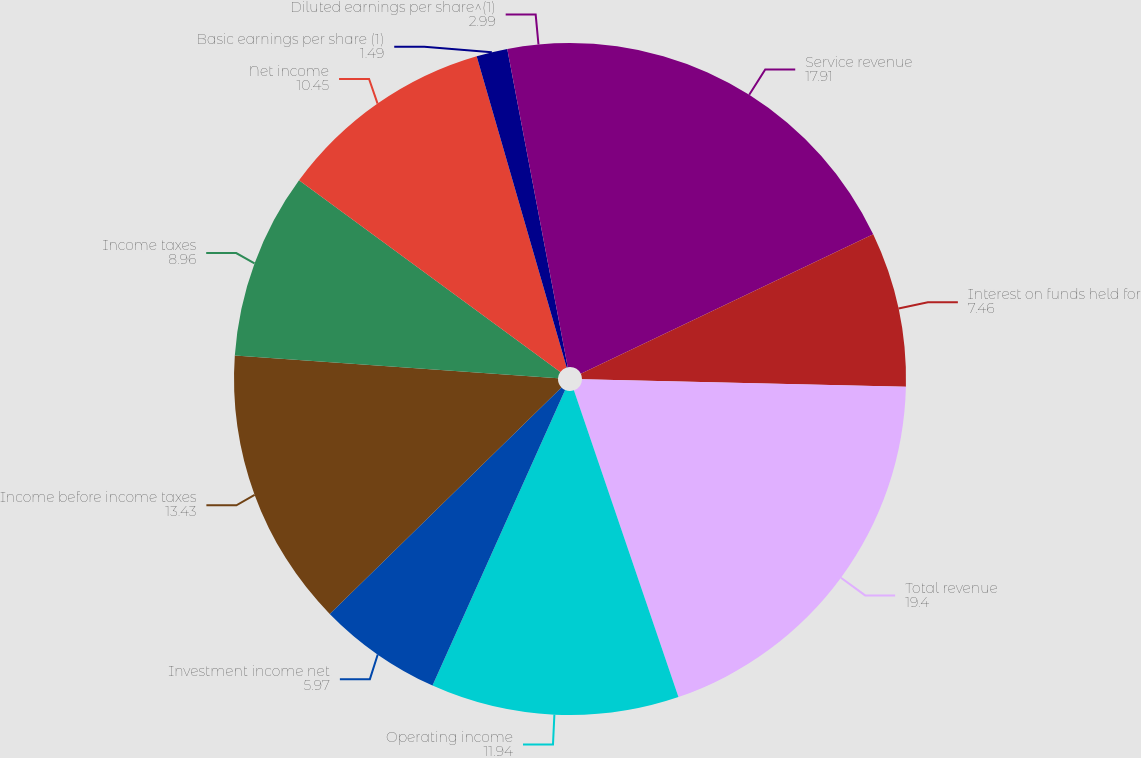<chart> <loc_0><loc_0><loc_500><loc_500><pie_chart><fcel>Service revenue<fcel>Interest on funds held for<fcel>Total revenue<fcel>Operating income<fcel>Investment income net<fcel>Income before income taxes<fcel>Income taxes<fcel>Net income<fcel>Basic earnings per share (1)<fcel>Diluted earnings per share^(1)<nl><fcel>17.91%<fcel>7.46%<fcel>19.4%<fcel>11.94%<fcel>5.97%<fcel>13.43%<fcel>8.96%<fcel>10.45%<fcel>1.49%<fcel>2.99%<nl></chart> 